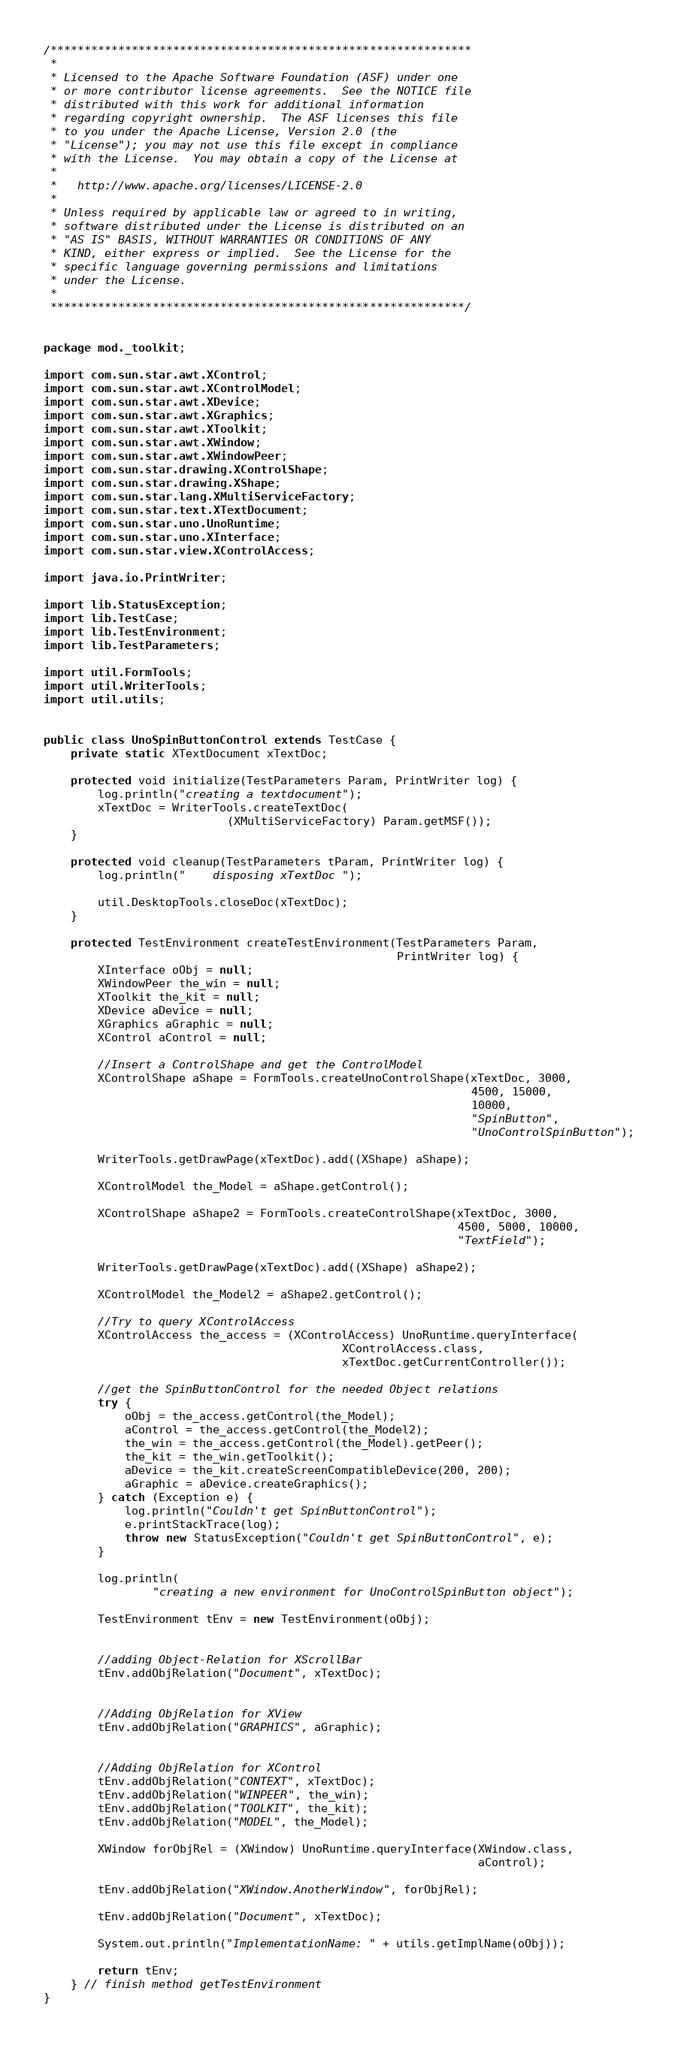<code> <loc_0><loc_0><loc_500><loc_500><_Java_>/**************************************************************
 * 
 * Licensed to the Apache Software Foundation (ASF) under one
 * or more contributor license agreements.  See the NOTICE file
 * distributed with this work for additional information
 * regarding copyright ownership.  The ASF licenses this file
 * to you under the Apache License, Version 2.0 (the
 * "License"); you may not use this file except in compliance
 * with the License.  You may obtain a copy of the License at
 * 
 *   http://www.apache.org/licenses/LICENSE-2.0
 * 
 * Unless required by applicable law or agreed to in writing,
 * software distributed under the License is distributed on an
 * "AS IS" BASIS, WITHOUT WARRANTIES OR CONDITIONS OF ANY
 * KIND, either express or implied.  See the License for the
 * specific language governing permissions and limitations
 * under the License.
 * 
 *************************************************************/


package mod._toolkit;

import com.sun.star.awt.XControl;
import com.sun.star.awt.XControlModel;
import com.sun.star.awt.XDevice;
import com.sun.star.awt.XGraphics;
import com.sun.star.awt.XToolkit;
import com.sun.star.awt.XWindow;
import com.sun.star.awt.XWindowPeer;
import com.sun.star.drawing.XControlShape;
import com.sun.star.drawing.XShape;
import com.sun.star.lang.XMultiServiceFactory;
import com.sun.star.text.XTextDocument;
import com.sun.star.uno.UnoRuntime;
import com.sun.star.uno.XInterface;
import com.sun.star.view.XControlAccess;

import java.io.PrintWriter;

import lib.StatusException;
import lib.TestCase;
import lib.TestEnvironment;
import lib.TestParameters;

import util.FormTools;
import util.WriterTools;
import util.utils;


public class UnoSpinButtonControl extends TestCase {
    private static XTextDocument xTextDoc;

    protected void initialize(TestParameters Param, PrintWriter log) {
        log.println("creating a textdocument");
        xTextDoc = WriterTools.createTextDoc(
                           (XMultiServiceFactory) Param.getMSF());
    }

    protected void cleanup(TestParameters tParam, PrintWriter log) {
        log.println("    disposing xTextDoc ");

        util.DesktopTools.closeDoc(xTextDoc);
    }

    protected TestEnvironment createTestEnvironment(TestParameters Param, 
                                                    PrintWriter log) {
        XInterface oObj = null;
        XWindowPeer the_win = null;
        XToolkit the_kit = null;
        XDevice aDevice = null;
        XGraphics aGraphic = null;
        XControl aControl = null;

        //Insert a ControlShape and get the ControlModel
        XControlShape aShape = FormTools.createUnoControlShape(xTextDoc, 3000, 
                                                               4500, 15000, 
                                                               10000, 
                                                               "SpinButton", 
                                                               "UnoControlSpinButton");

        WriterTools.getDrawPage(xTextDoc).add((XShape) aShape);

        XControlModel the_Model = aShape.getControl();

        XControlShape aShape2 = FormTools.createControlShape(xTextDoc, 3000, 
                                                             4500, 5000, 10000, 
                                                             "TextField");

        WriterTools.getDrawPage(xTextDoc).add((XShape) aShape2);

        XControlModel the_Model2 = aShape2.getControl();

        //Try to query XControlAccess
        XControlAccess the_access = (XControlAccess) UnoRuntime.queryInterface(
                                            XControlAccess.class, 
                                            xTextDoc.getCurrentController());

        //get the SpinButtonControl for the needed Object relations
        try {
            oObj = the_access.getControl(the_Model);
            aControl = the_access.getControl(the_Model2);
            the_win = the_access.getControl(the_Model).getPeer();
            the_kit = the_win.getToolkit();
            aDevice = the_kit.createScreenCompatibleDevice(200, 200);
            aGraphic = aDevice.createGraphics();
        } catch (Exception e) {
            log.println("Couldn't get SpinButtonControl");
            e.printStackTrace(log);
            throw new StatusException("Couldn't get SpinButtonControl", e);
        }

        log.println(
                "creating a new environment for UnoControlSpinButton object");

        TestEnvironment tEnv = new TestEnvironment(oObj);


        //adding Object-Relation for XScrollBar
        tEnv.addObjRelation("Document", xTextDoc);


        //Adding ObjRelation for XView
        tEnv.addObjRelation("GRAPHICS", aGraphic);


        //Adding ObjRelation for XControl
        tEnv.addObjRelation("CONTEXT", xTextDoc);
        tEnv.addObjRelation("WINPEER", the_win);
        tEnv.addObjRelation("TOOLKIT", the_kit);
        tEnv.addObjRelation("MODEL", the_Model);

        XWindow forObjRel = (XWindow) UnoRuntime.queryInterface(XWindow.class, 
                                                                aControl);

        tEnv.addObjRelation("XWindow.AnotherWindow", forObjRel);

        tEnv.addObjRelation("Document", xTextDoc);

        System.out.println("ImplementationName: " + utils.getImplName(oObj));

        return tEnv;
    } // finish method getTestEnvironment
}
</code> 